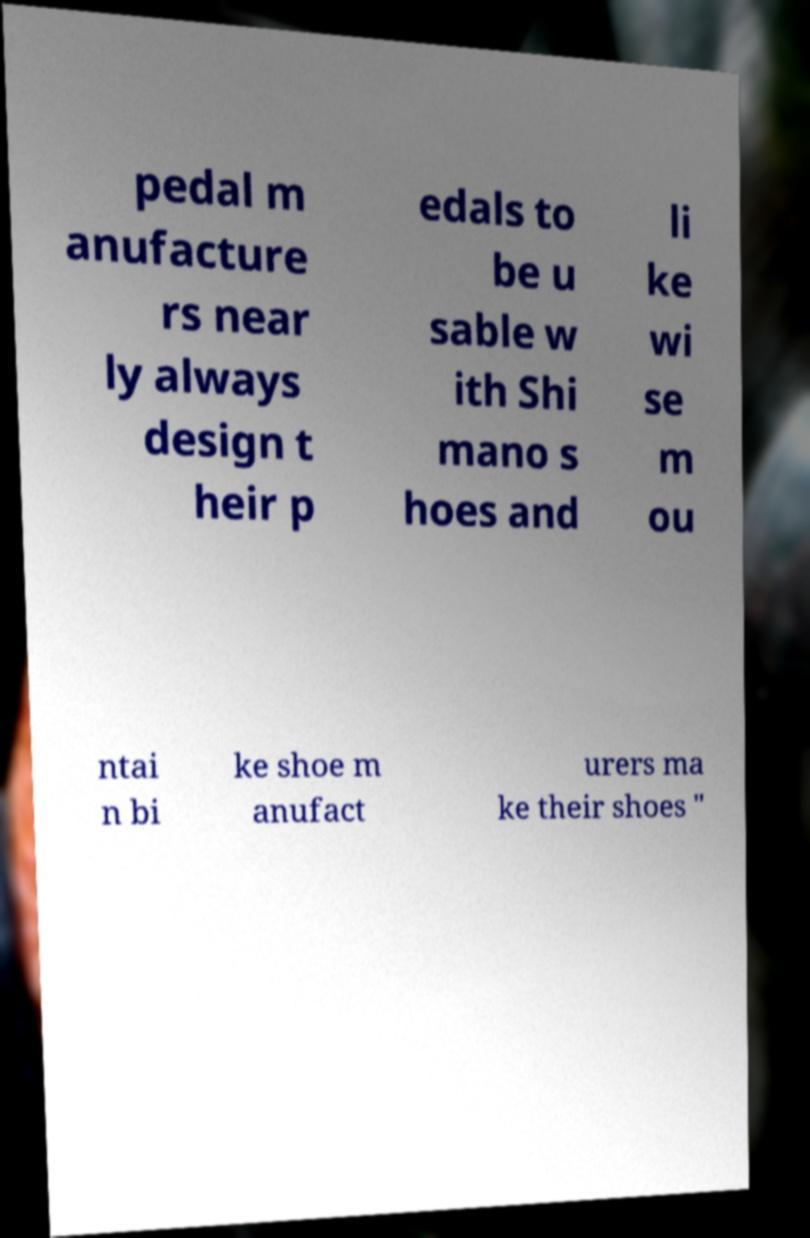For documentation purposes, I need the text within this image transcribed. Could you provide that? pedal m anufacture rs near ly always design t heir p edals to be u sable w ith Shi mano s hoes and li ke wi se m ou ntai n bi ke shoe m anufact urers ma ke their shoes " 